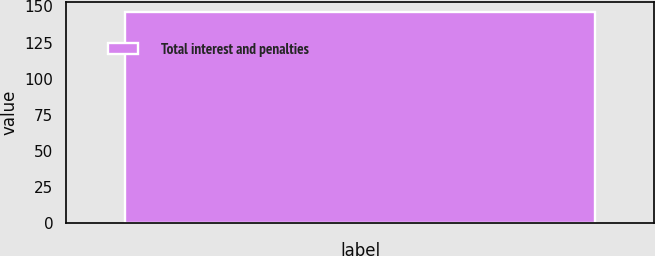Convert chart to OTSL. <chart><loc_0><loc_0><loc_500><loc_500><bar_chart><fcel>Total interest and penalties<nl><fcel>146<nl></chart> 